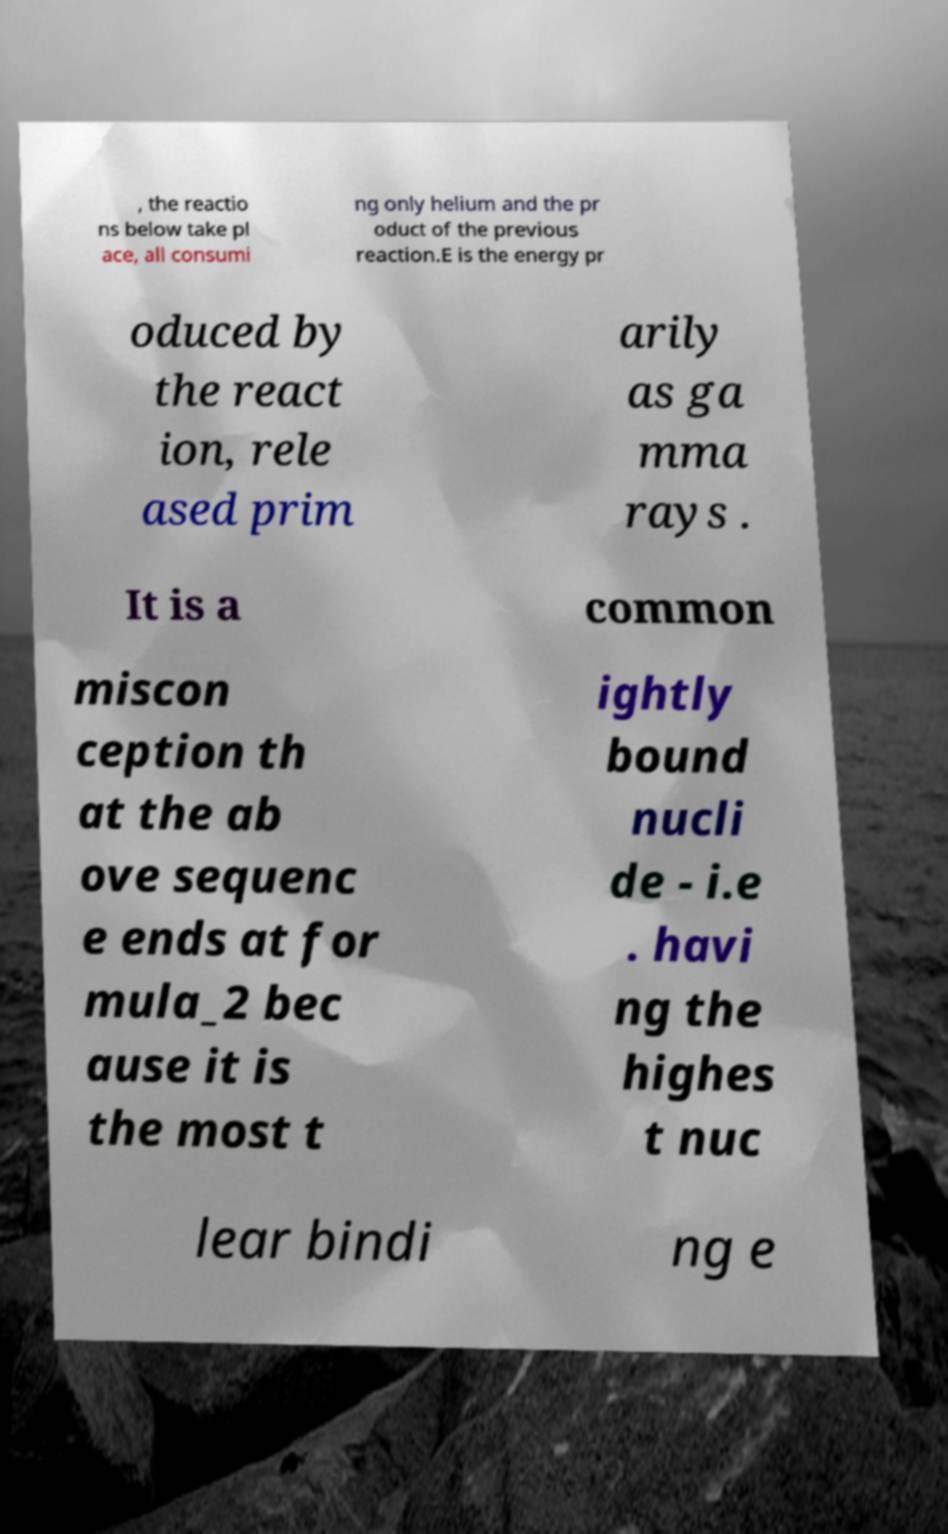Can you read and provide the text displayed in the image?This photo seems to have some interesting text. Can you extract and type it out for me? , the reactio ns below take pl ace, all consumi ng only helium and the pr oduct of the previous reaction.E is the energy pr oduced by the react ion, rele ased prim arily as ga mma rays . It is a common miscon ception th at the ab ove sequenc e ends at for mula_2 bec ause it is the most t ightly bound nucli de - i.e . havi ng the highes t nuc lear bindi ng e 